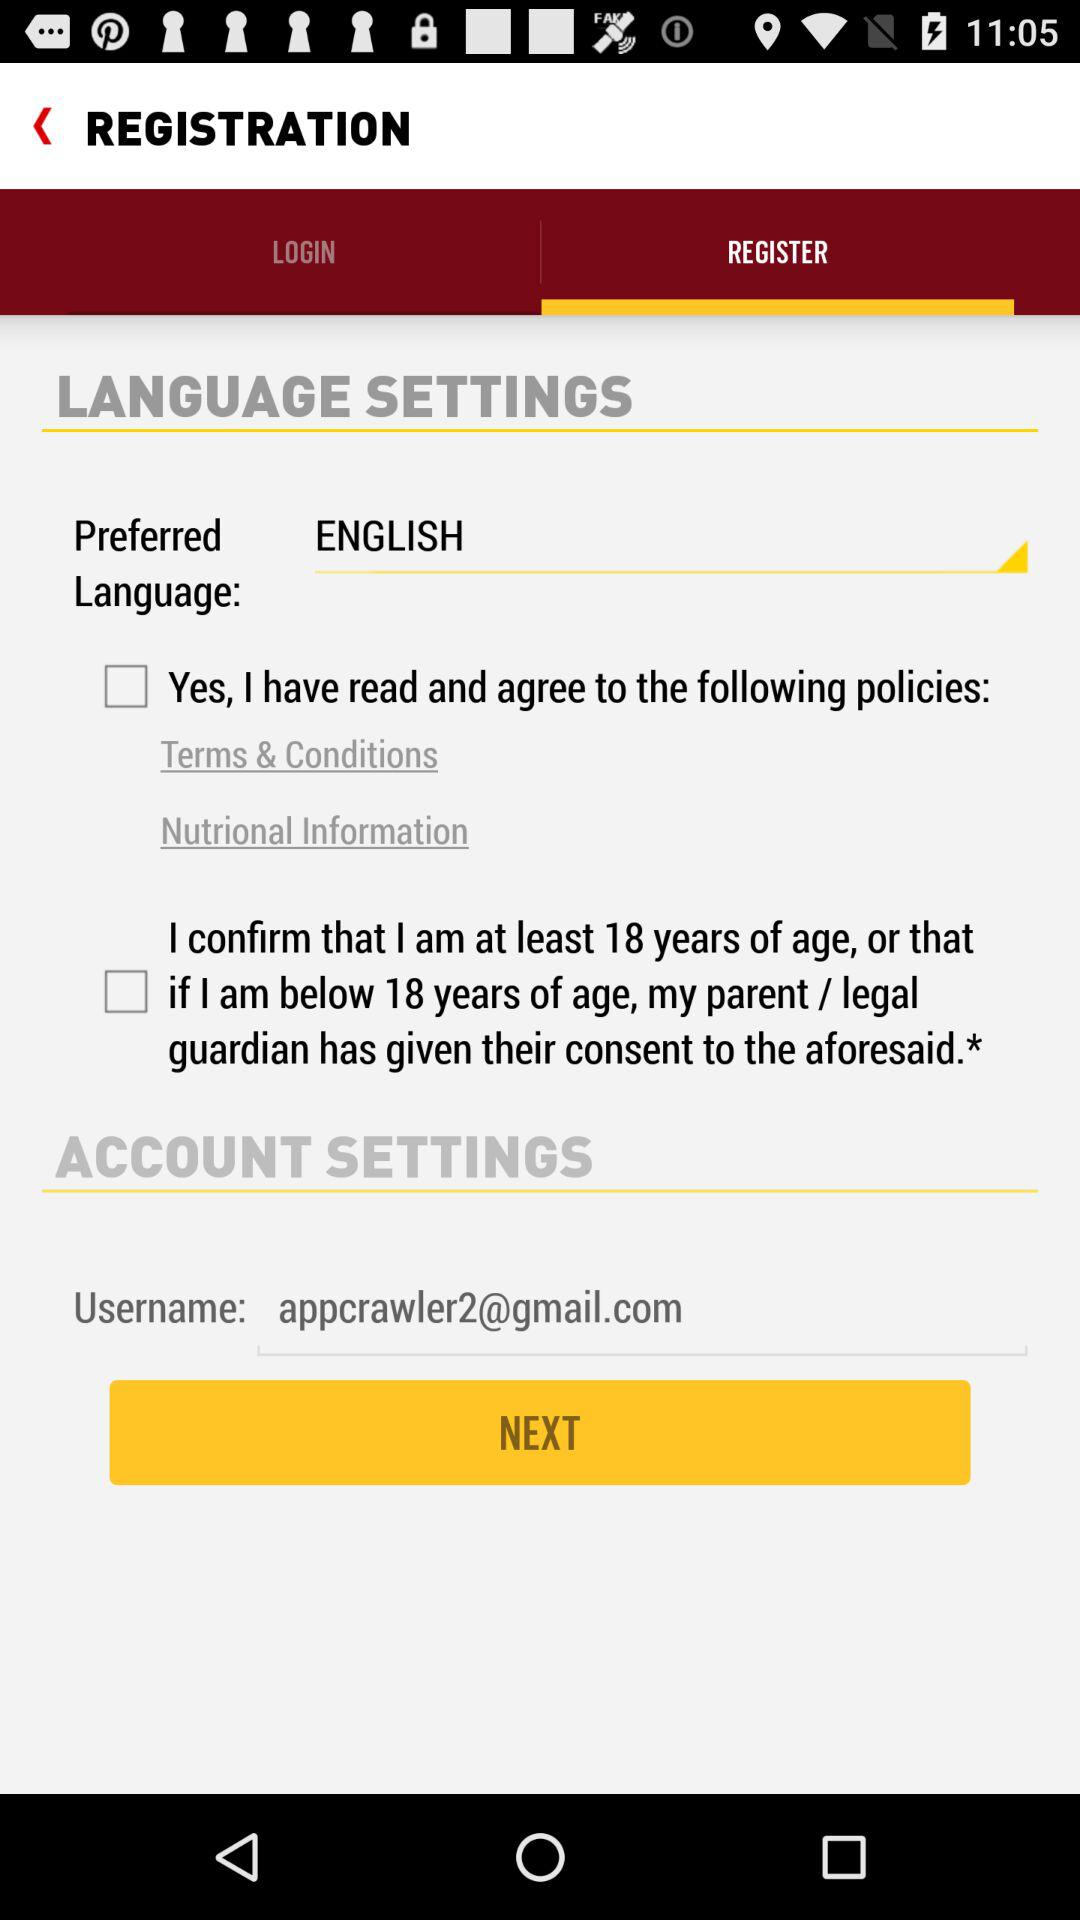What is the email address of the user? The email address of the user is appcrawler2@gmail.com. 